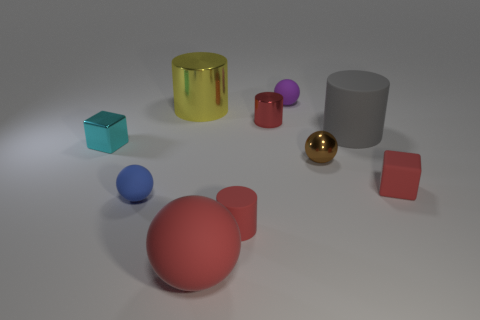Subtract all tiny matte cylinders. How many cylinders are left? 3 Subtract all blue spheres. How many spheres are left? 3 Subtract 0 gray spheres. How many objects are left? 10 Subtract all spheres. How many objects are left? 6 Subtract 1 blocks. How many blocks are left? 1 Subtract all red spheres. Subtract all blue cylinders. How many spheres are left? 3 Subtract all red cubes. How many purple balls are left? 1 Subtract all cylinders. Subtract all small red cylinders. How many objects are left? 4 Add 6 tiny blue matte objects. How many tiny blue matte objects are left? 7 Add 2 small cyan metal cubes. How many small cyan metal cubes exist? 3 